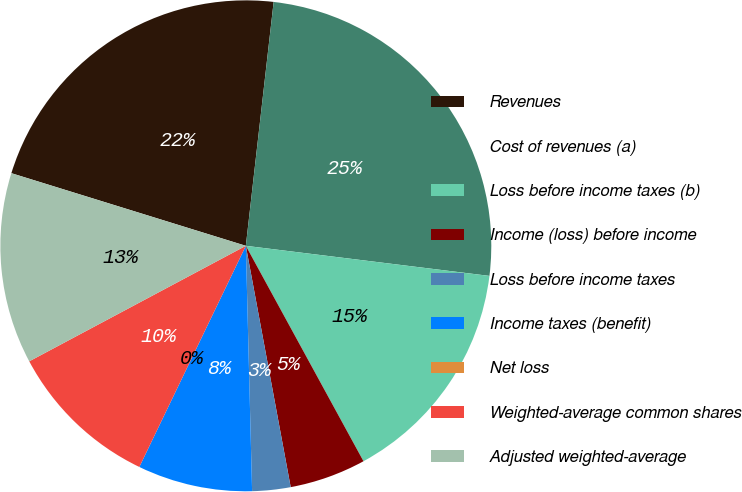Convert chart. <chart><loc_0><loc_0><loc_500><loc_500><pie_chart><fcel>Revenues<fcel>Cost of revenues (a)<fcel>Loss before income taxes (b)<fcel>Income (loss) before income<fcel>Loss before income taxes<fcel>Income taxes (benefit)<fcel>Net loss<fcel>Weighted-average common shares<fcel>Adjusted weighted-average<nl><fcel>22.03%<fcel>25.15%<fcel>15.09%<fcel>5.03%<fcel>2.52%<fcel>7.55%<fcel>0.0%<fcel>10.06%<fcel>12.58%<nl></chart> 